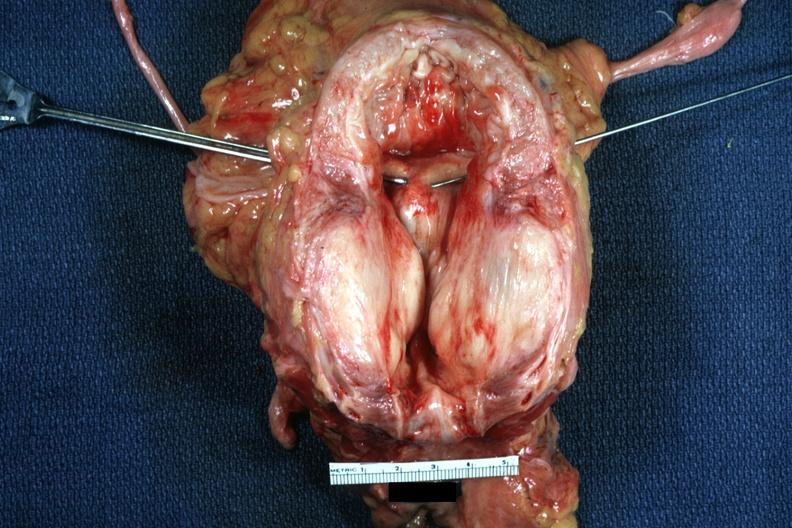does this image show excellent very large gland hypertrophied bladder?
Answer the question using a single word or phrase. Yes 